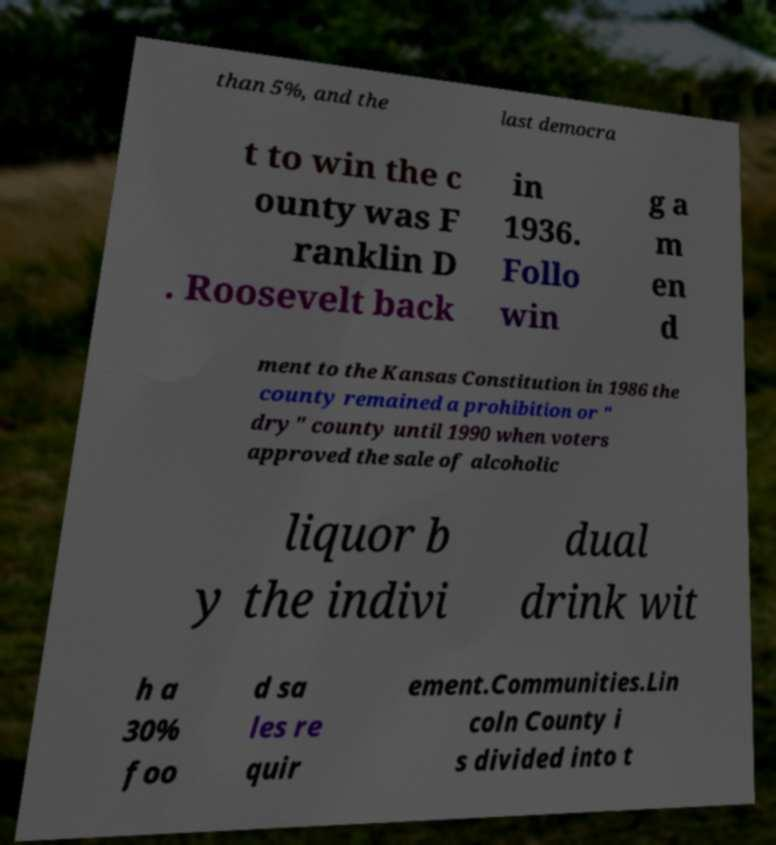I need the written content from this picture converted into text. Can you do that? than 5%, and the last democra t to win the c ounty was F ranklin D . Roosevelt back in 1936. Follo win g a m en d ment to the Kansas Constitution in 1986 the county remained a prohibition or " dry" county until 1990 when voters approved the sale of alcoholic liquor b y the indivi dual drink wit h a 30% foo d sa les re quir ement.Communities.Lin coln County i s divided into t 